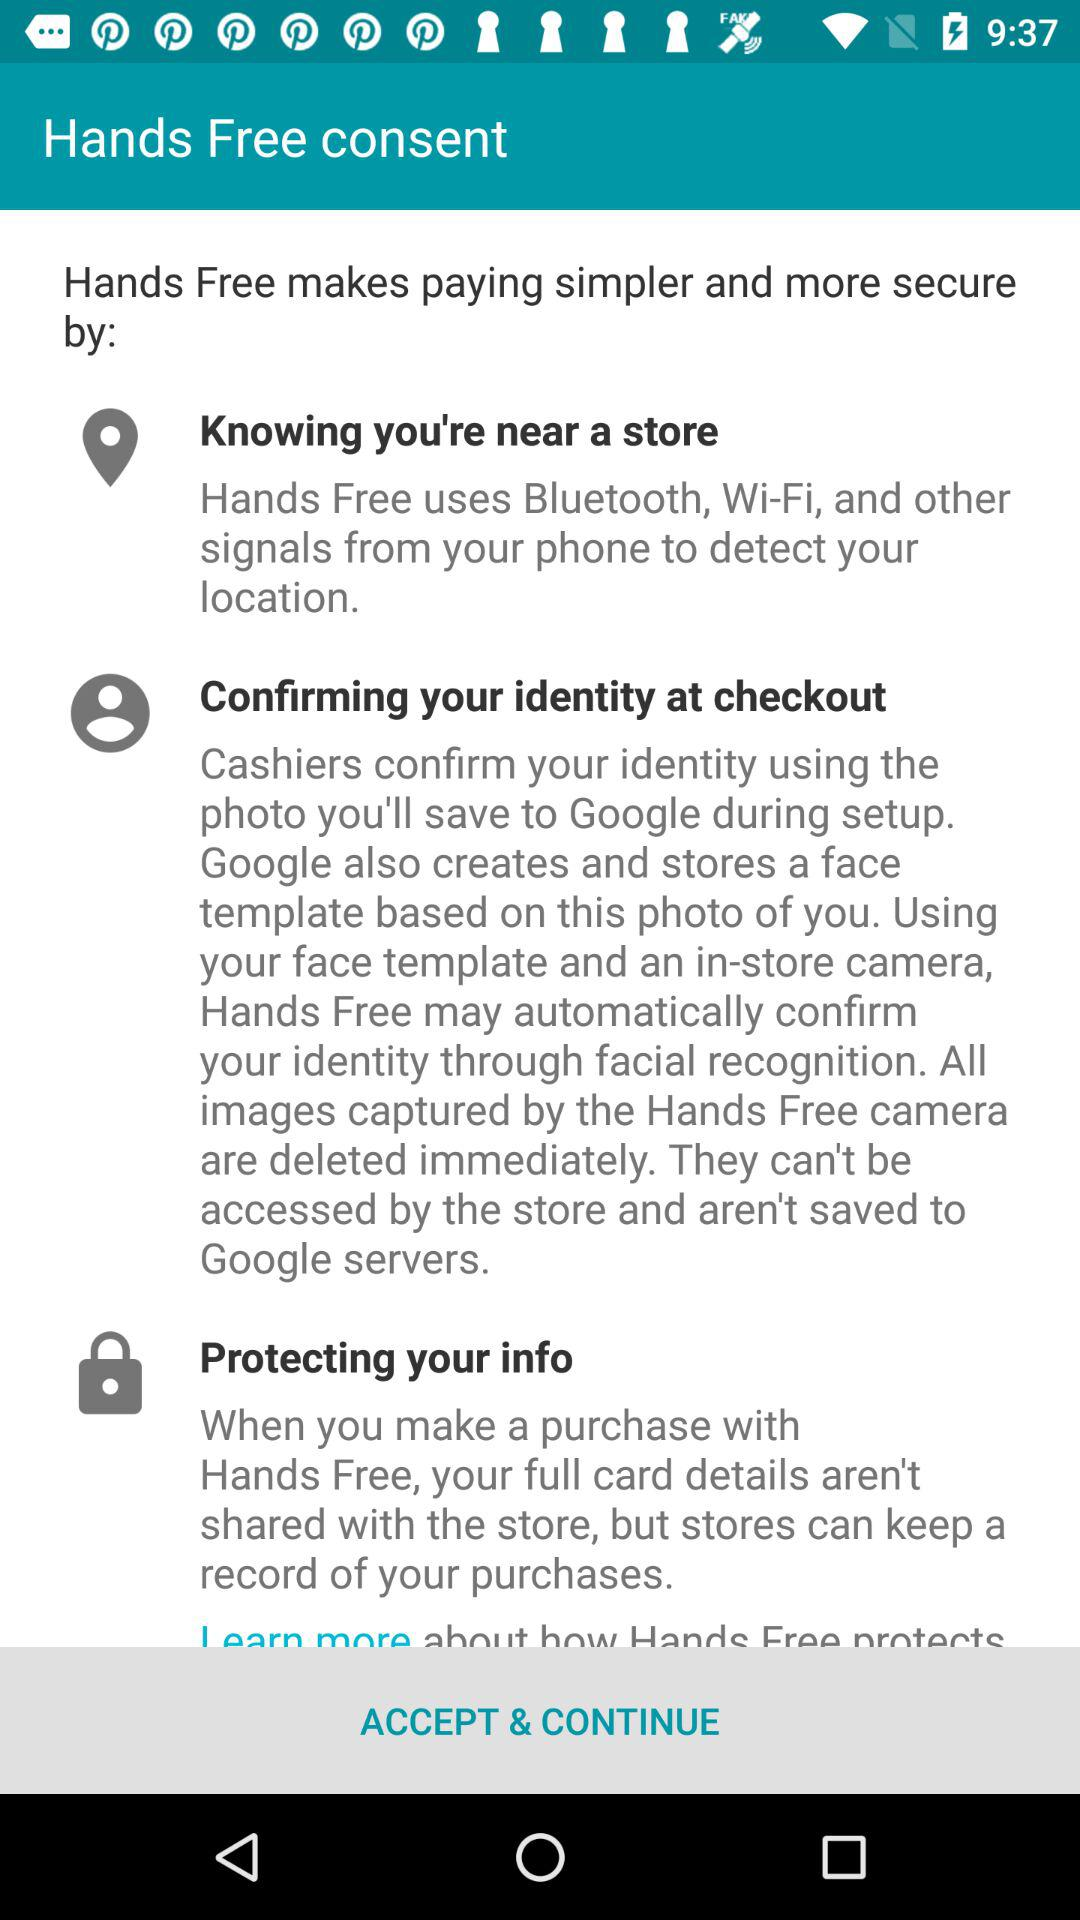What are the steps by which hands free makes paying simpler?
When the provided information is insufficient, respond with <no answer>. <no answer> 